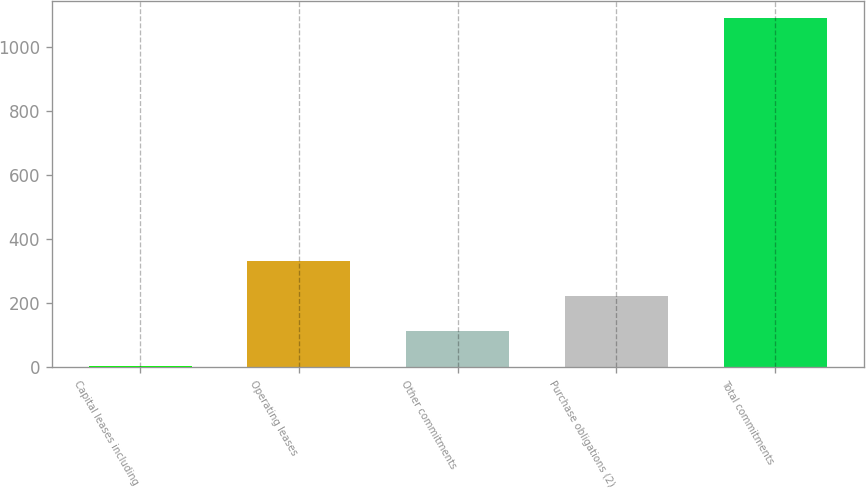Convert chart. <chart><loc_0><loc_0><loc_500><loc_500><bar_chart><fcel>Capital leases including<fcel>Operating leases<fcel>Other commitments<fcel>Purchase obligations (2)<fcel>Total commitments<nl><fcel>5<fcel>330.5<fcel>113.5<fcel>222<fcel>1090<nl></chart> 